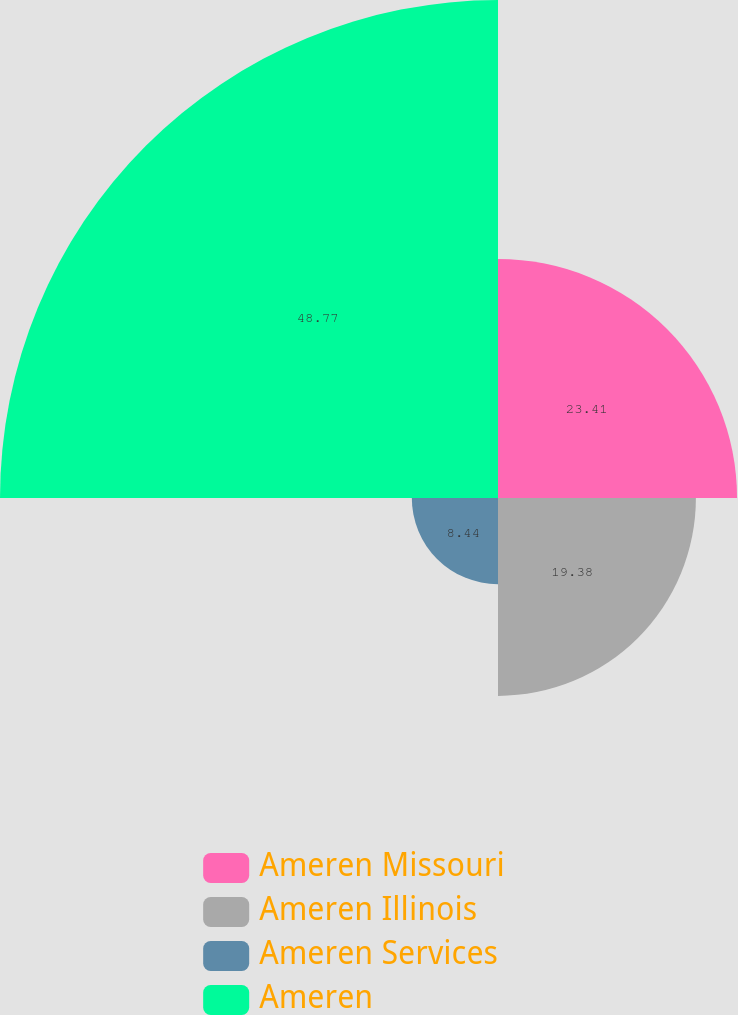Convert chart to OTSL. <chart><loc_0><loc_0><loc_500><loc_500><pie_chart><fcel>Ameren Missouri<fcel>Ameren Illinois<fcel>Ameren Services<fcel>Ameren<nl><fcel>23.41%<fcel>19.38%<fcel>8.44%<fcel>48.77%<nl></chart> 